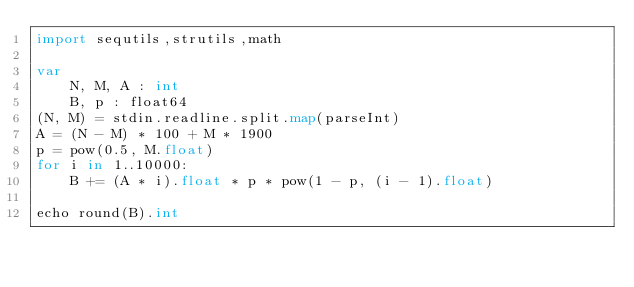<code> <loc_0><loc_0><loc_500><loc_500><_Nim_>import sequtils,strutils,math

var
    N, M, A : int
    B, p : float64
(N, M) = stdin.readline.split.map(parseInt)
A = (N - M) * 100 + M * 1900
p = pow(0.5, M.float)
for i in 1..10000:
    B += (A * i).float * p * pow(1 - p, (i - 1).float)

echo round(B).int</code> 